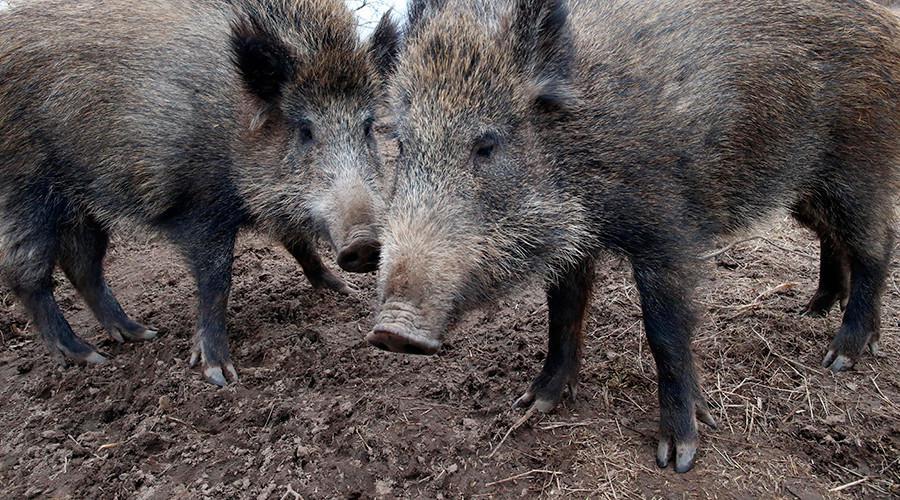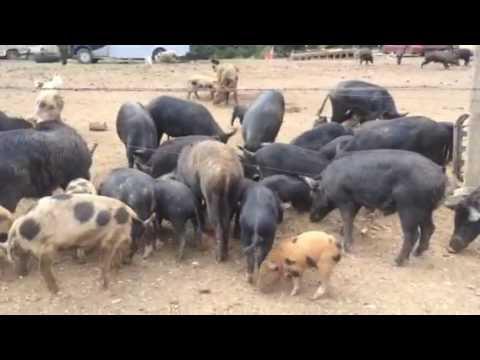The first image is the image on the left, the second image is the image on the right. Considering the images on both sides, is "The left image contains no more than two wild boars." valid? Answer yes or no. Yes. The first image is the image on the left, the second image is the image on the right. Given the left and right images, does the statement "The left photo contains two or fewer boars." hold true? Answer yes or no. Yes. 